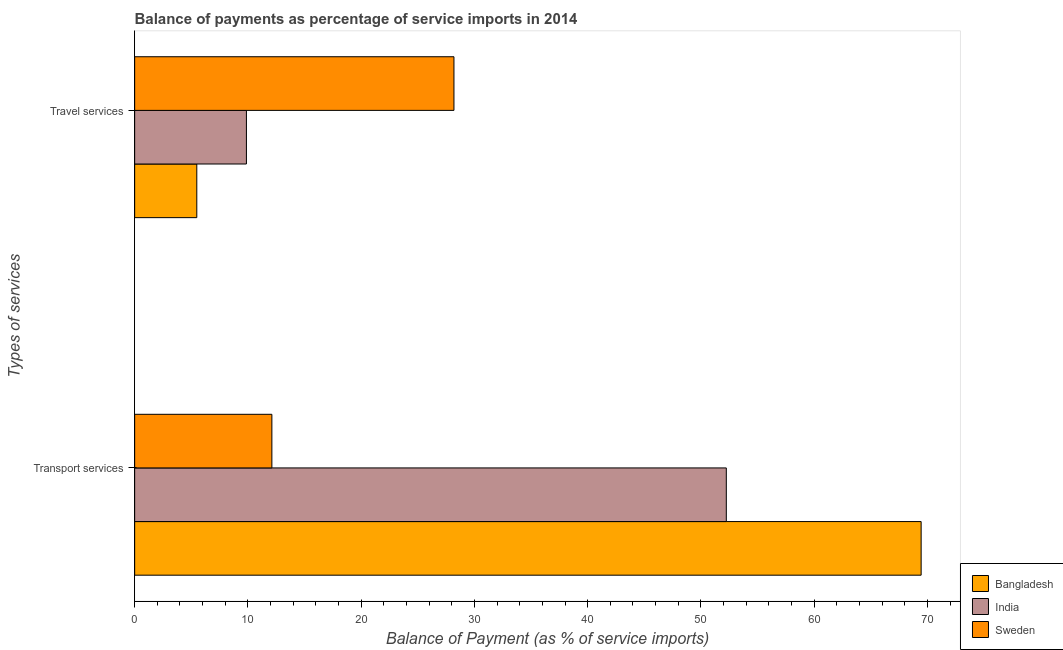How many different coloured bars are there?
Keep it short and to the point. 3. Are the number of bars per tick equal to the number of legend labels?
Offer a terse response. Yes. How many bars are there on the 1st tick from the top?
Your response must be concise. 3. How many bars are there on the 2nd tick from the bottom?
Your response must be concise. 3. What is the label of the 1st group of bars from the top?
Your answer should be compact. Travel services. What is the balance of payments of travel services in India?
Your response must be concise. 9.87. Across all countries, what is the maximum balance of payments of travel services?
Make the answer very short. 28.19. Across all countries, what is the minimum balance of payments of travel services?
Offer a terse response. 5.49. In which country was the balance of payments of travel services maximum?
Offer a very short reply. Sweden. What is the total balance of payments of travel services in the graph?
Offer a very short reply. 43.55. What is the difference between the balance of payments of transport services in Bangladesh and that in Sweden?
Your answer should be very brief. 57.33. What is the difference between the balance of payments of transport services in Bangladesh and the balance of payments of travel services in India?
Offer a very short reply. 59.57. What is the average balance of payments of transport services per country?
Provide a short and direct response. 44.6. What is the difference between the balance of payments of transport services and balance of payments of travel services in Bangladesh?
Offer a very short reply. 63.95. What is the ratio of the balance of payments of travel services in Bangladesh to that in Sweden?
Make the answer very short. 0.19. Is the balance of payments of travel services in Bangladesh less than that in India?
Make the answer very short. Yes. Are all the bars in the graph horizontal?
Your answer should be very brief. Yes. How many countries are there in the graph?
Keep it short and to the point. 3. What is the difference between two consecutive major ticks on the X-axis?
Your response must be concise. 10. Are the values on the major ticks of X-axis written in scientific E-notation?
Provide a succinct answer. No. Does the graph contain any zero values?
Provide a succinct answer. No. Does the graph contain grids?
Your answer should be compact. No. How are the legend labels stacked?
Offer a terse response. Vertical. What is the title of the graph?
Make the answer very short. Balance of payments as percentage of service imports in 2014. What is the label or title of the X-axis?
Keep it short and to the point. Balance of Payment (as % of service imports). What is the label or title of the Y-axis?
Give a very brief answer. Types of services. What is the Balance of Payment (as % of service imports) in Bangladesh in Transport services?
Give a very brief answer. 69.44. What is the Balance of Payment (as % of service imports) in India in Transport services?
Give a very brief answer. 52.24. What is the Balance of Payment (as % of service imports) in Sweden in Transport services?
Your answer should be very brief. 12.12. What is the Balance of Payment (as % of service imports) of Bangladesh in Travel services?
Your answer should be compact. 5.49. What is the Balance of Payment (as % of service imports) in India in Travel services?
Your answer should be compact. 9.87. What is the Balance of Payment (as % of service imports) in Sweden in Travel services?
Ensure brevity in your answer.  28.19. Across all Types of services, what is the maximum Balance of Payment (as % of service imports) in Bangladesh?
Provide a succinct answer. 69.44. Across all Types of services, what is the maximum Balance of Payment (as % of service imports) of India?
Ensure brevity in your answer.  52.24. Across all Types of services, what is the maximum Balance of Payment (as % of service imports) of Sweden?
Ensure brevity in your answer.  28.19. Across all Types of services, what is the minimum Balance of Payment (as % of service imports) of Bangladesh?
Your response must be concise. 5.49. Across all Types of services, what is the minimum Balance of Payment (as % of service imports) of India?
Provide a short and direct response. 9.87. Across all Types of services, what is the minimum Balance of Payment (as % of service imports) in Sweden?
Your answer should be very brief. 12.12. What is the total Balance of Payment (as % of service imports) of Bangladesh in the graph?
Your answer should be very brief. 74.93. What is the total Balance of Payment (as % of service imports) of India in the graph?
Give a very brief answer. 62.11. What is the total Balance of Payment (as % of service imports) of Sweden in the graph?
Provide a short and direct response. 40.31. What is the difference between the Balance of Payment (as % of service imports) in Bangladesh in Transport services and that in Travel services?
Provide a short and direct response. 63.95. What is the difference between the Balance of Payment (as % of service imports) of India in Transport services and that in Travel services?
Your answer should be very brief. 42.37. What is the difference between the Balance of Payment (as % of service imports) in Sweden in Transport services and that in Travel services?
Provide a succinct answer. -16.08. What is the difference between the Balance of Payment (as % of service imports) in Bangladesh in Transport services and the Balance of Payment (as % of service imports) in India in Travel services?
Offer a terse response. 59.57. What is the difference between the Balance of Payment (as % of service imports) of Bangladesh in Transport services and the Balance of Payment (as % of service imports) of Sweden in Travel services?
Give a very brief answer. 41.25. What is the difference between the Balance of Payment (as % of service imports) in India in Transport services and the Balance of Payment (as % of service imports) in Sweden in Travel services?
Your response must be concise. 24.05. What is the average Balance of Payment (as % of service imports) of Bangladesh per Types of services?
Keep it short and to the point. 37.46. What is the average Balance of Payment (as % of service imports) in India per Types of services?
Make the answer very short. 31.05. What is the average Balance of Payment (as % of service imports) in Sweden per Types of services?
Provide a short and direct response. 20.15. What is the difference between the Balance of Payment (as % of service imports) of Bangladesh and Balance of Payment (as % of service imports) of India in Transport services?
Your answer should be very brief. 17.2. What is the difference between the Balance of Payment (as % of service imports) in Bangladesh and Balance of Payment (as % of service imports) in Sweden in Transport services?
Provide a short and direct response. 57.33. What is the difference between the Balance of Payment (as % of service imports) in India and Balance of Payment (as % of service imports) in Sweden in Transport services?
Your answer should be very brief. 40.12. What is the difference between the Balance of Payment (as % of service imports) in Bangladesh and Balance of Payment (as % of service imports) in India in Travel services?
Your response must be concise. -4.38. What is the difference between the Balance of Payment (as % of service imports) of Bangladesh and Balance of Payment (as % of service imports) of Sweden in Travel services?
Provide a short and direct response. -22.71. What is the difference between the Balance of Payment (as % of service imports) in India and Balance of Payment (as % of service imports) in Sweden in Travel services?
Provide a short and direct response. -18.32. What is the ratio of the Balance of Payment (as % of service imports) of Bangladesh in Transport services to that in Travel services?
Your answer should be very brief. 12.65. What is the ratio of the Balance of Payment (as % of service imports) of India in Transport services to that in Travel services?
Make the answer very short. 5.29. What is the ratio of the Balance of Payment (as % of service imports) in Sweden in Transport services to that in Travel services?
Ensure brevity in your answer.  0.43. What is the difference between the highest and the second highest Balance of Payment (as % of service imports) in Bangladesh?
Your answer should be compact. 63.95. What is the difference between the highest and the second highest Balance of Payment (as % of service imports) of India?
Offer a very short reply. 42.37. What is the difference between the highest and the second highest Balance of Payment (as % of service imports) of Sweden?
Offer a terse response. 16.08. What is the difference between the highest and the lowest Balance of Payment (as % of service imports) of Bangladesh?
Provide a short and direct response. 63.95. What is the difference between the highest and the lowest Balance of Payment (as % of service imports) of India?
Give a very brief answer. 42.37. What is the difference between the highest and the lowest Balance of Payment (as % of service imports) of Sweden?
Your answer should be very brief. 16.08. 